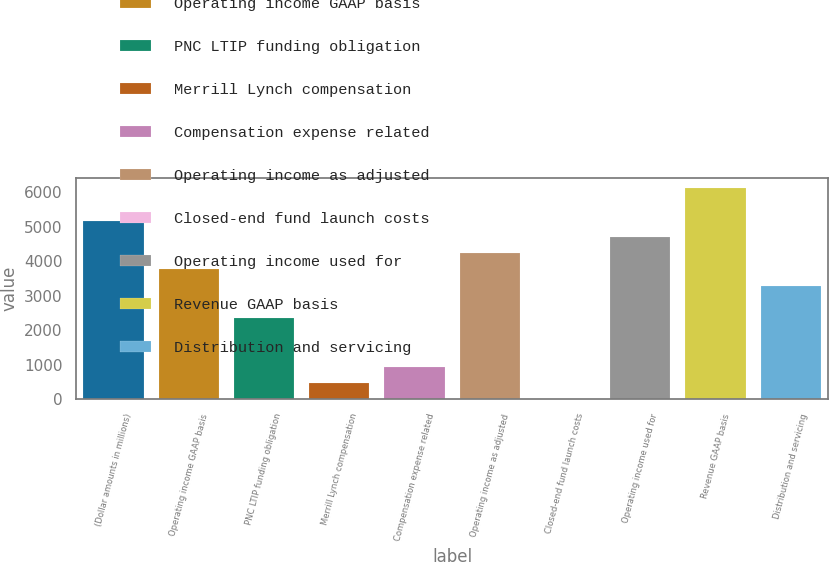<chart> <loc_0><loc_0><loc_500><loc_500><bar_chart><fcel>(Dollar amounts in millions)<fcel>Operating income GAAP basis<fcel>PNC LTIP funding obligation<fcel>Merrill Lynch compensation<fcel>Compensation expense related<fcel>Operating income as adjusted<fcel>Closed-end fund launch costs<fcel>Operating income used for<fcel>Revenue GAAP basis<fcel>Distribution and servicing<nl><fcel>5169.8<fcel>3760.4<fcel>2351<fcel>471.8<fcel>941.6<fcel>4230.2<fcel>2<fcel>4700<fcel>6109.4<fcel>3290.6<nl></chart> 